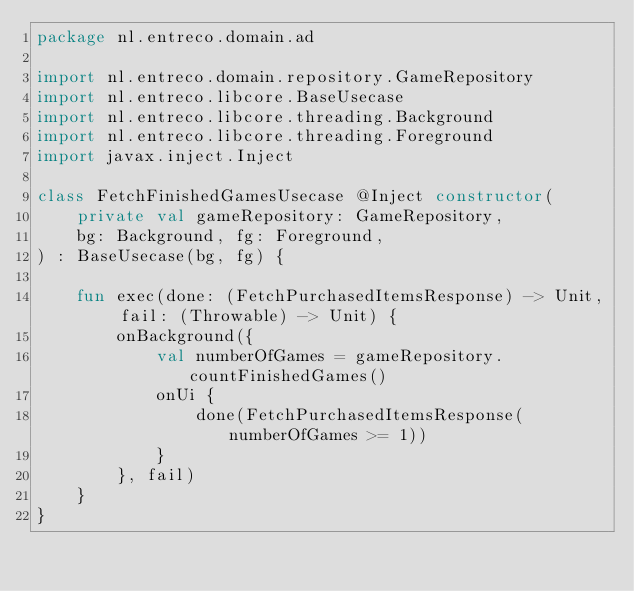<code> <loc_0><loc_0><loc_500><loc_500><_Kotlin_>package nl.entreco.domain.ad

import nl.entreco.domain.repository.GameRepository
import nl.entreco.libcore.BaseUsecase
import nl.entreco.libcore.threading.Background
import nl.entreco.libcore.threading.Foreground
import javax.inject.Inject

class FetchFinishedGamesUsecase @Inject constructor(
    private val gameRepository: GameRepository,
    bg: Background, fg: Foreground,
) : BaseUsecase(bg, fg) {

    fun exec(done: (FetchPurchasedItemsResponse) -> Unit, fail: (Throwable) -> Unit) {
        onBackground({
            val numberOfGames = gameRepository.countFinishedGames()
            onUi {
                done(FetchPurchasedItemsResponse(numberOfGames >= 1))
            }
        }, fail)
    }
}</code> 